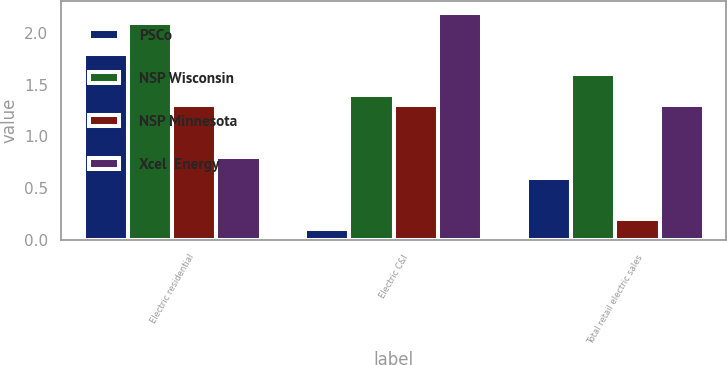<chart> <loc_0><loc_0><loc_500><loc_500><stacked_bar_chart><ecel><fcel>Electric residential<fcel>Electric C&I<fcel>Total retail electric sales<nl><fcel>PSCo<fcel>1.8<fcel>0.1<fcel>0.6<nl><fcel>NSP Wisconsin<fcel>2.1<fcel>1.4<fcel>1.6<nl><fcel>NSP Minnesota<fcel>1.3<fcel>1.3<fcel>0.2<nl><fcel>Xcel  Energy<fcel>0.8<fcel>2.2<fcel>1.3<nl></chart> 